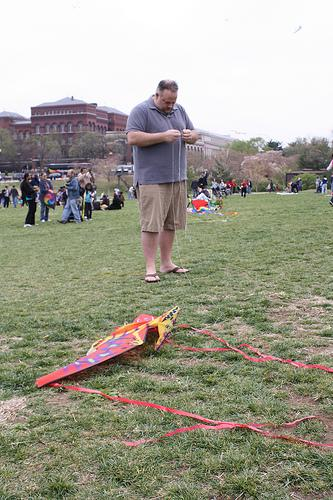Question: what color is the grass?
Choices:
A. Brown.
B. Yellow.
C. Grey.
D. Green.
Answer with the letter. Answer: D Question: who is untangling kite string?
Choices:
A. The person on the ground.
B. The adult.
C. The male.
D. The man in shorts.
Answer with the letter. Answer: D Question: where is the kite?
Choices:
A. In the air.
B. On the ground.
C. Flying.
D. Stuck in the tree.
Answer with the letter. Answer: B Question: what is the building made out of?
Choices:
A. Concrete.
B. Wood.
C. Cement.
D. Brick.
Answer with the letter. Answer: D Question: what color is the sky?
Choices:
A. Blue.
B. Pink.
C. Black.
D. Gray.
Answer with the letter. Answer: D 